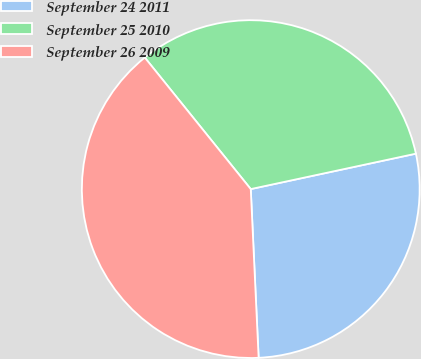Convert chart to OTSL. <chart><loc_0><loc_0><loc_500><loc_500><pie_chart><fcel>September 24 2011<fcel>September 25 2010<fcel>September 26 2009<nl><fcel>27.62%<fcel>32.43%<fcel>39.95%<nl></chart> 